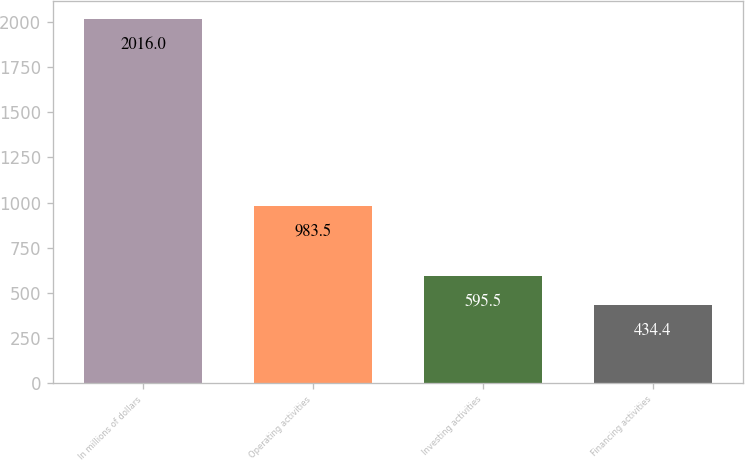<chart> <loc_0><loc_0><loc_500><loc_500><bar_chart><fcel>In millions of dollars<fcel>Operating activities<fcel>Investing activities<fcel>Financing activities<nl><fcel>2016<fcel>983.5<fcel>595.5<fcel>434.4<nl></chart> 